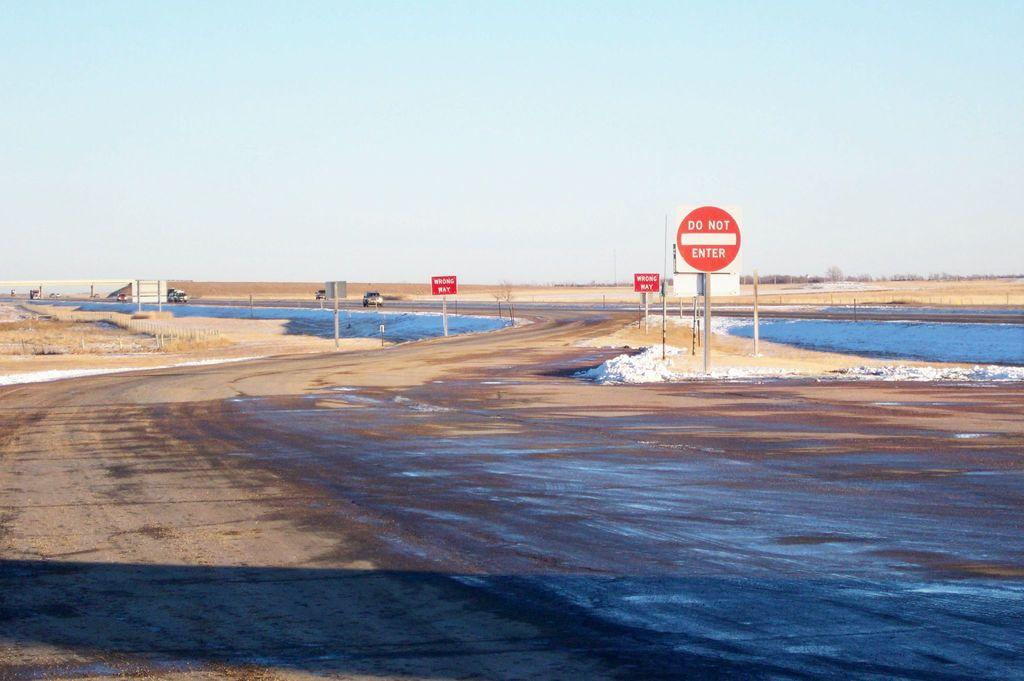<image>
Relay a brief, clear account of the picture shown. A Do Not Enter sign is posted near the beach. 